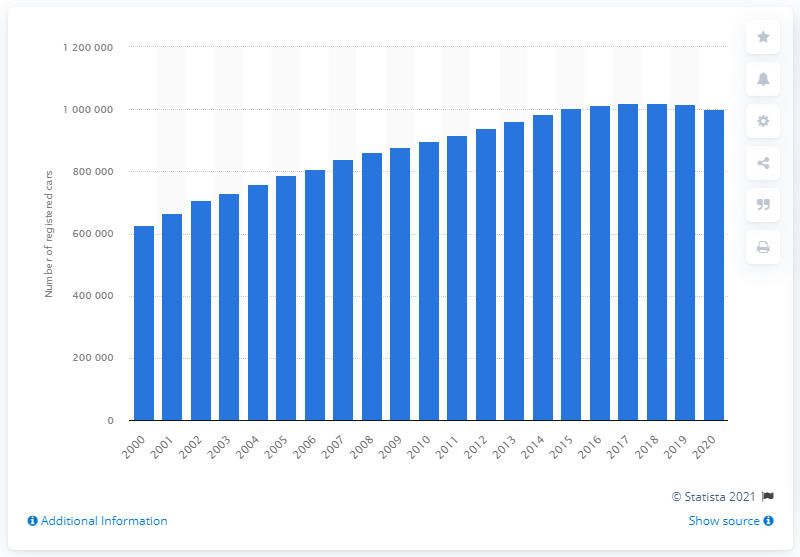Specify some key components in this picture. The total appeared to have slipped into a downward trend in 2018. 